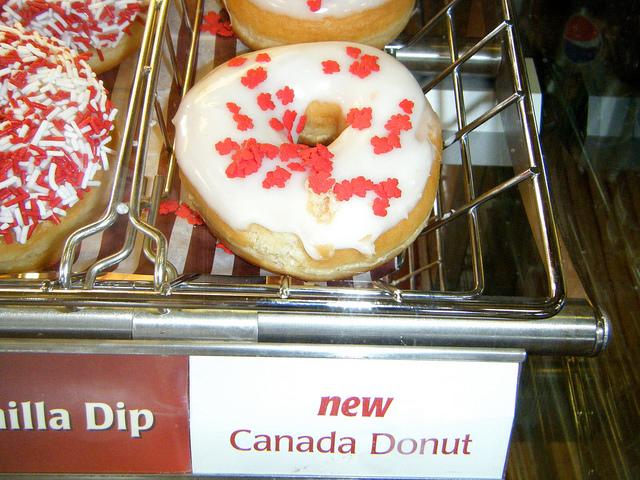Are the donut toppings all the same color?
Keep it brief. No. What is the name of the NEW donut?
Give a very brief answer. Canada donut. What kind of pastry is this?
Keep it brief. Donut. 